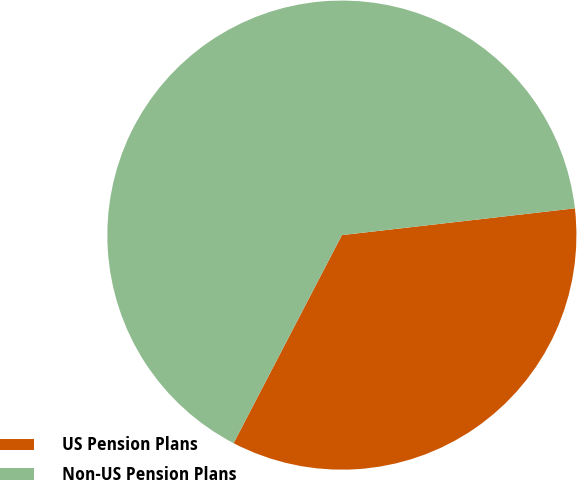<chart> <loc_0><loc_0><loc_500><loc_500><pie_chart><fcel>US Pension Plans<fcel>Non-US Pension Plans<nl><fcel>34.46%<fcel>65.54%<nl></chart> 